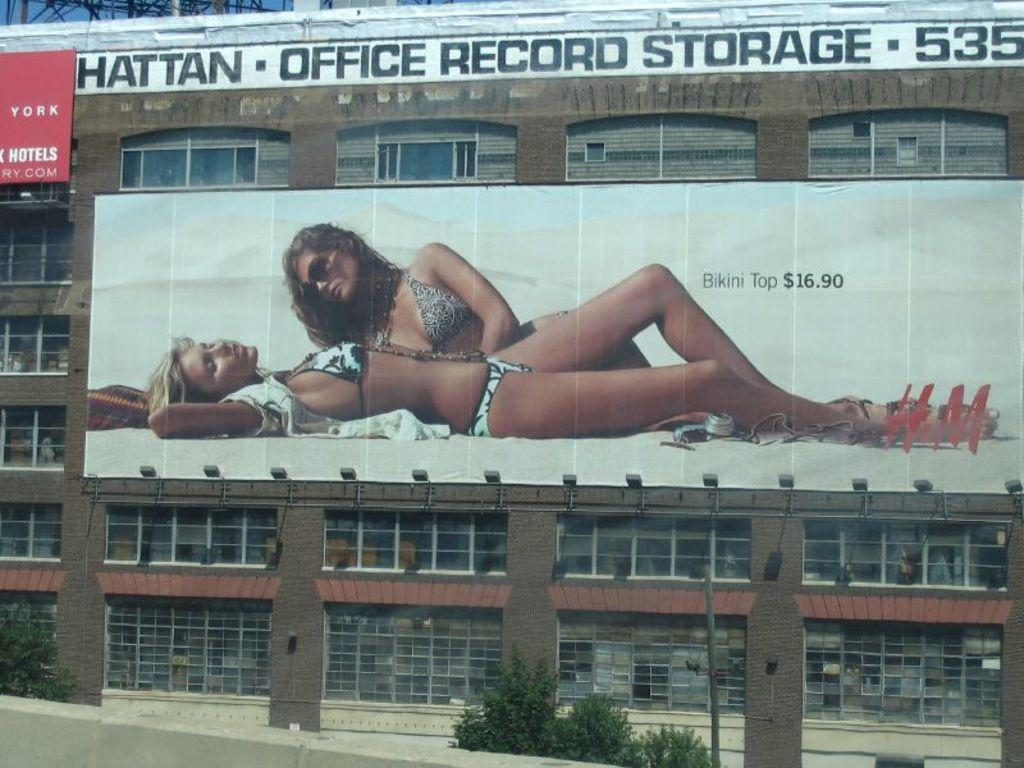<image>
Render a clear and concise summary of the photo. A large billboard for $16.90 Binkini Tops on a building shows two women tanning. 